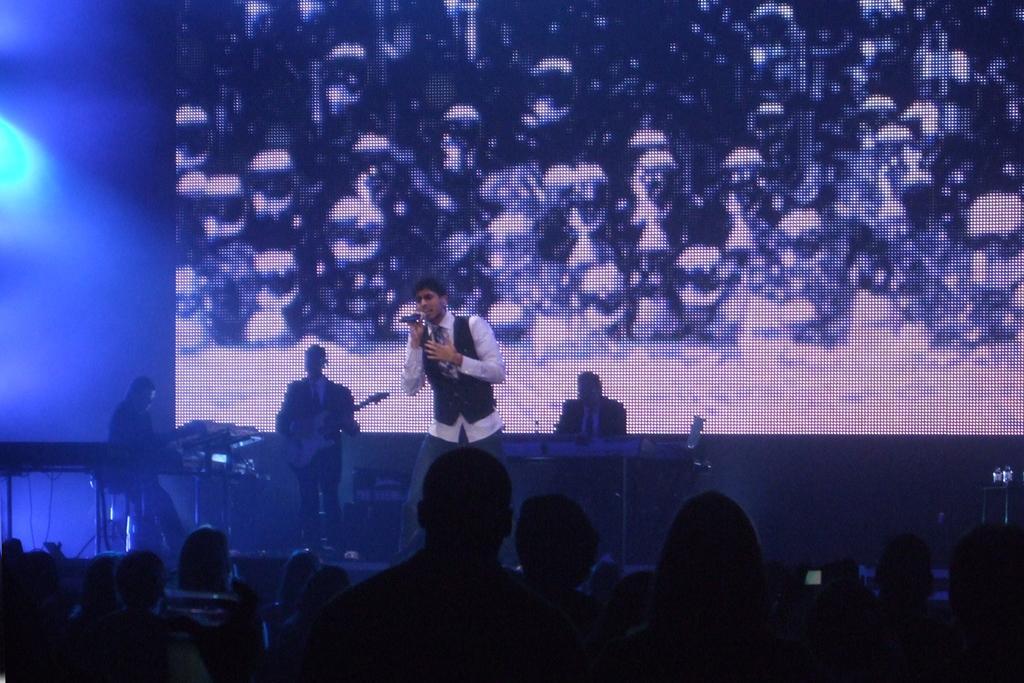Can you describe this image briefly? In this image there are four people standing on the dais. In the center there is a man holding a microphone in his hand. Behind him there are people playing musical instruments. Behind them there is a screen. There are pictures displayed on the screen. At the bottom there are heads of the people. 